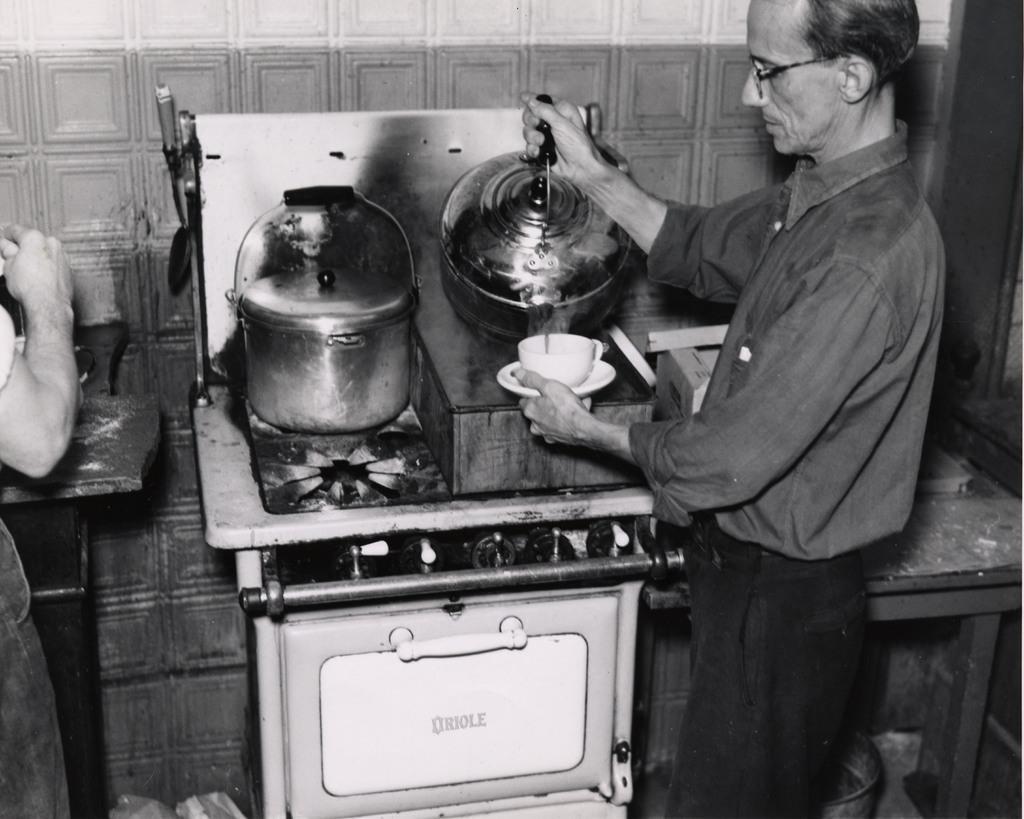Please provide a concise description of this image. In this image we can see a teapot on a stove. Behind the teapot we can see a wall. At the bottom we can see a white object. On the right side, we can see a table and a person holding a saucer and a teapot. On the left side we can see a person. 